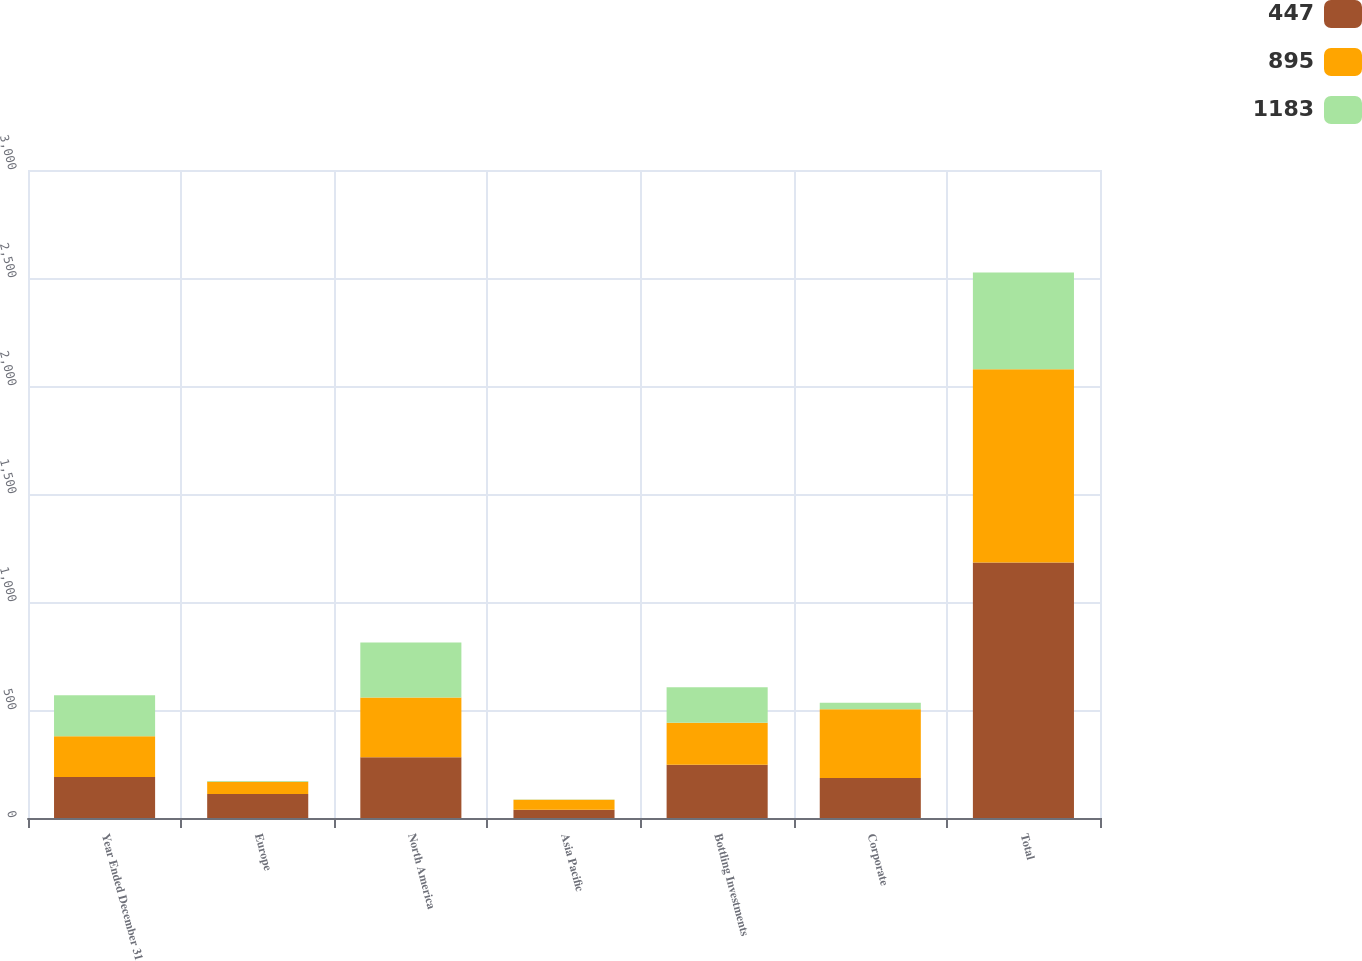<chart> <loc_0><loc_0><loc_500><loc_500><stacked_bar_chart><ecel><fcel>Year Ended December 31<fcel>Europe<fcel>North America<fcel>Asia Pacific<fcel>Bottling Investments<fcel>Corporate<fcel>Total<nl><fcel>447<fcel>189.5<fcel>111<fcel>281<fcel>38<fcel>247<fcel>185<fcel>1183<nl><fcel>895<fcel>189.5<fcel>57<fcel>277<fcel>47<fcel>194<fcel>318<fcel>895<nl><fcel>1183<fcel>189.5<fcel>3<fcel>255<fcel>1<fcel>164<fcel>30<fcel>447<nl></chart> 